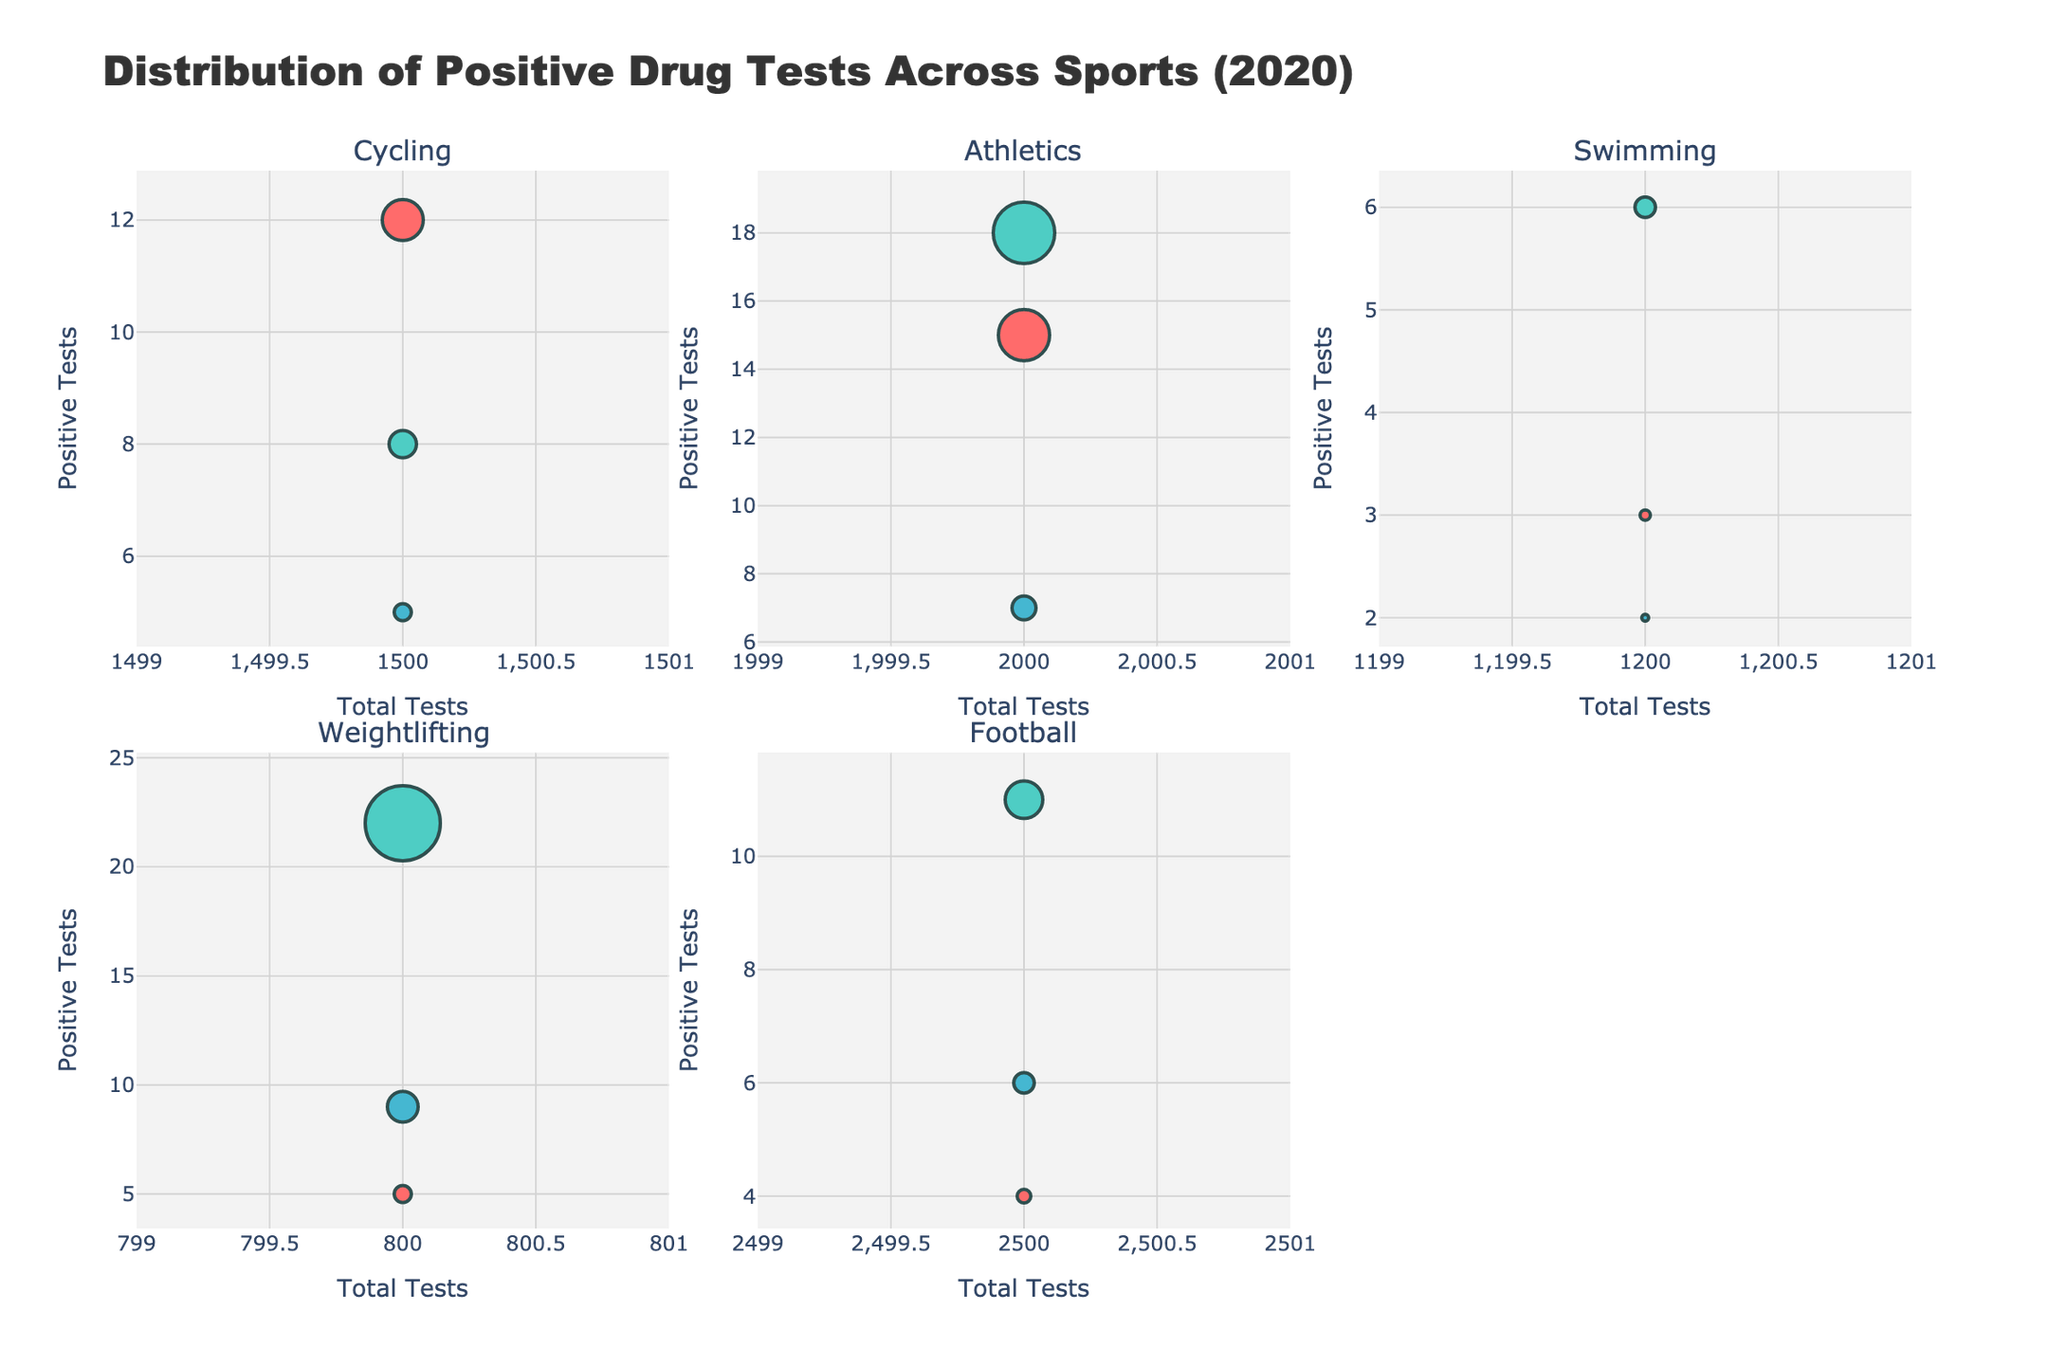What is the title of the figure? The title is generally located at the top of the figure and provides an overview of what the figure represents.
Answer: Distribution of Positive Drug Tests Across Sports (2020) What are the sports categories shown in the figure? The sports categories are the titles of each individual subplot. You can see them as the labels above each subplot.
Answer: Cycling, Athletics, Swimming, Weightlifting, Football Which substance has the largest marker in the Weightlifting subplot? The size of the marker represents the number of positive tests. The largest marker in Weightlifting is observed by visually checking the subplot.
Answer: Steroids What is the total number of positive tests for Steroids across all sports? Add the number of positive tests for Steroids from all sports subplots: Cycling (8), Athletics (18), Swimming (6), Weightlifting (22), and Football (11).
Answer: 65 Which sport had the fewest total tests conducted? The total tests conducted are indicated along the x-axis. The sport with the marker closest to the origin (0,0) in the subplots will have the fewest total tests.
Answer: Weightlifting How does the number of positive EPO tests in Athletics compare to those in Swimming? Look at the markers in the Athletics and Swimming subplots for EPO. Compare the y-coordinate (number of positive tests) of EPO markers in both sports.
Answer: Athletics has more positive EPO tests than Swimming What is the average number of positive tests for Growth Hormone across all sports? Add the number of positive tests for Growth Hormone in all sports and divide by the number of sports: Cycling (5), Athletics (7), Swimming (2), Weightlifting (9), Football (6). The average is (5+7+2+9+6)/5.
Answer: 5.8 Which substance in Athletics has the smallest marker size? The marker size in the scatter plot represents the number of positive tests. Identify the smallest marker in the Athletics subplot.
Answer: Growth Hormone How does the number of positive tests for Growth Hormone in Cycling compare to that in Football? Look at the markers in the Cycling and Football subplots for Growth Hormone. Compare the y-coordinates (number of positive tests) of these markers.
Answer: Cycling has fewer positive Growth Hormone tests than Football 